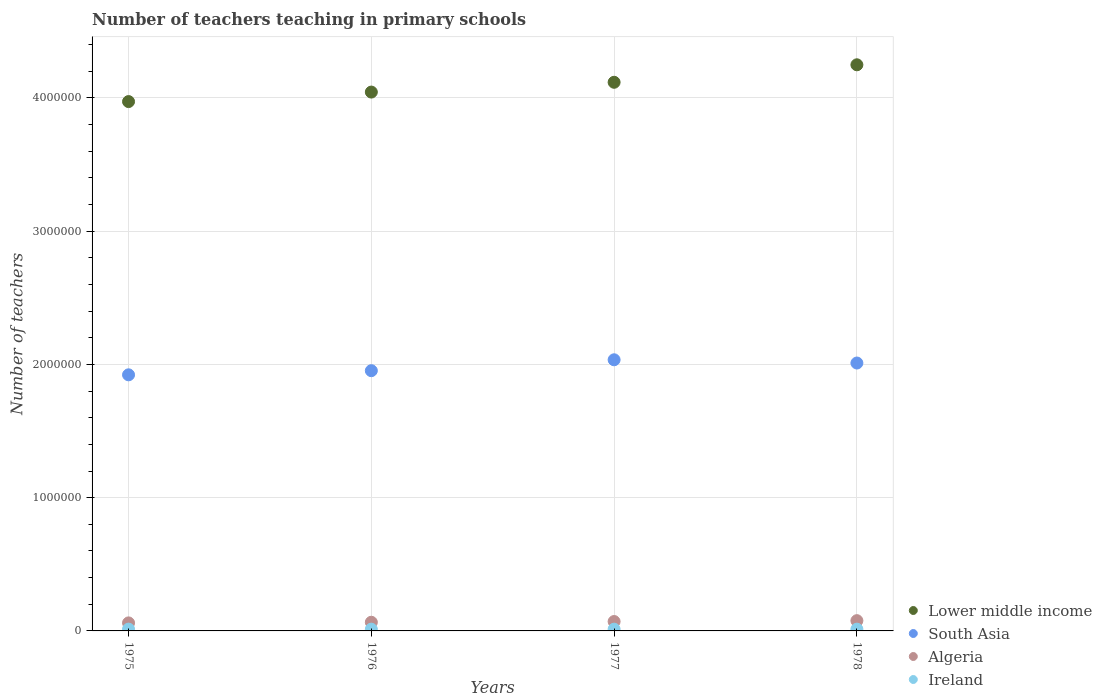Is the number of dotlines equal to the number of legend labels?
Your answer should be compact. Yes. What is the number of teachers teaching in primary schools in Algeria in 1975?
Keep it short and to the point. 6.02e+04. Across all years, what is the maximum number of teachers teaching in primary schools in South Asia?
Your answer should be very brief. 2.03e+06. Across all years, what is the minimum number of teachers teaching in primary schools in Algeria?
Your response must be concise. 6.02e+04. In which year was the number of teachers teaching in primary schools in Algeria maximum?
Offer a very short reply. 1978. In which year was the number of teachers teaching in primary schools in Ireland minimum?
Your answer should be very brief. 1976. What is the total number of teachers teaching in primary schools in South Asia in the graph?
Make the answer very short. 7.92e+06. What is the difference between the number of teachers teaching in primary schools in Algeria in 1976 and that in 1977?
Ensure brevity in your answer.  -5455. What is the difference between the number of teachers teaching in primary schools in Lower middle income in 1976 and the number of teachers teaching in primary schools in Algeria in 1977?
Your answer should be compact. 3.97e+06. What is the average number of teachers teaching in primary schools in Lower middle income per year?
Give a very brief answer. 4.10e+06. In the year 1977, what is the difference between the number of teachers teaching in primary schools in Ireland and number of teachers teaching in primary schools in South Asia?
Give a very brief answer. -2.02e+06. What is the ratio of the number of teachers teaching in primary schools in Algeria in 1975 to that in 1976?
Your answer should be compact. 0.93. Is the number of teachers teaching in primary schools in Algeria in 1977 less than that in 1978?
Ensure brevity in your answer.  Yes. Is the difference between the number of teachers teaching in primary schools in Ireland in 1975 and 1977 greater than the difference between the number of teachers teaching in primary schools in South Asia in 1975 and 1977?
Ensure brevity in your answer.  Yes. What is the difference between the highest and the second highest number of teachers teaching in primary schools in Ireland?
Offer a terse response. 155. What is the difference between the highest and the lowest number of teachers teaching in primary schools in Algeria?
Offer a very short reply. 1.68e+04. In how many years, is the number of teachers teaching in primary schools in South Asia greater than the average number of teachers teaching in primary schools in South Asia taken over all years?
Give a very brief answer. 2. Is the number of teachers teaching in primary schools in South Asia strictly greater than the number of teachers teaching in primary schools in Lower middle income over the years?
Your answer should be very brief. No. How many dotlines are there?
Keep it short and to the point. 4. How many years are there in the graph?
Provide a short and direct response. 4. What is the difference between two consecutive major ticks on the Y-axis?
Ensure brevity in your answer.  1.00e+06. Are the values on the major ticks of Y-axis written in scientific E-notation?
Offer a terse response. No. Does the graph contain any zero values?
Your answer should be very brief. No. Does the graph contain grids?
Your response must be concise. Yes. What is the title of the graph?
Your response must be concise. Number of teachers teaching in primary schools. What is the label or title of the Y-axis?
Your response must be concise. Number of teachers. What is the Number of teachers of Lower middle income in 1975?
Ensure brevity in your answer.  3.97e+06. What is the Number of teachers in South Asia in 1975?
Make the answer very short. 1.92e+06. What is the Number of teachers in Algeria in 1975?
Your answer should be compact. 6.02e+04. What is the Number of teachers in Ireland in 1975?
Your answer should be compact. 1.34e+04. What is the Number of teachers of Lower middle income in 1976?
Make the answer very short. 4.04e+06. What is the Number of teachers in South Asia in 1976?
Keep it short and to the point. 1.95e+06. What is the Number of teachers of Algeria in 1976?
Provide a short and direct response. 6.50e+04. What is the Number of teachers of Ireland in 1976?
Give a very brief answer. 1.31e+04. What is the Number of teachers of Lower middle income in 1977?
Offer a very short reply. 4.12e+06. What is the Number of teachers of South Asia in 1977?
Give a very brief answer. 2.03e+06. What is the Number of teachers in Algeria in 1977?
Make the answer very short. 7.05e+04. What is the Number of teachers of Ireland in 1977?
Provide a succinct answer. 1.31e+04. What is the Number of teachers of Lower middle income in 1978?
Your answer should be very brief. 4.25e+06. What is the Number of teachers of South Asia in 1978?
Keep it short and to the point. 2.01e+06. What is the Number of teachers in Algeria in 1978?
Provide a short and direct response. 7.70e+04. What is the Number of teachers in Ireland in 1978?
Offer a very short reply. 1.32e+04. Across all years, what is the maximum Number of teachers of Lower middle income?
Provide a short and direct response. 4.25e+06. Across all years, what is the maximum Number of teachers in South Asia?
Your answer should be very brief. 2.03e+06. Across all years, what is the maximum Number of teachers in Algeria?
Your answer should be very brief. 7.70e+04. Across all years, what is the maximum Number of teachers of Ireland?
Give a very brief answer. 1.34e+04. Across all years, what is the minimum Number of teachers of Lower middle income?
Your response must be concise. 3.97e+06. Across all years, what is the minimum Number of teachers of South Asia?
Provide a short and direct response. 1.92e+06. Across all years, what is the minimum Number of teachers in Algeria?
Provide a short and direct response. 6.02e+04. Across all years, what is the minimum Number of teachers in Ireland?
Give a very brief answer. 1.31e+04. What is the total Number of teachers of Lower middle income in the graph?
Provide a succinct answer. 1.64e+07. What is the total Number of teachers in South Asia in the graph?
Provide a succinct answer. 7.92e+06. What is the total Number of teachers in Algeria in the graph?
Offer a terse response. 2.73e+05. What is the total Number of teachers in Ireland in the graph?
Your response must be concise. 5.28e+04. What is the difference between the Number of teachers of Lower middle income in 1975 and that in 1976?
Your answer should be compact. -7.14e+04. What is the difference between the Number of teachers of South Asia in 1975 and that in 1976?
Offer a very short reply. -3.11e+04. What is the difference between the Number of teachers in Algeria in 1975 and that in 1976?
Offer a very short reply. -4864. What is the difference between the Number of teachers of Ireland in 1975 and that in 1976?
Offer a very short reply. 337. What is the difference between the Number of teachers of Lower middle income in 1975 and that in 1977?
Provide a succinct answer. -1.45e+05. What is the difference between the Number of teachers in South Asia in 1975 and that in 1977?
Provide a succinct answer. -1.13e+05. What is the difference between the Number of teachers in Algeria in 1975 and that in 1977?
Your answer should be very brief. -1.03e+04. What is the difference between the Number of teachers of Ireland in 1975 and that in 1977?
Offer a very short reply. 321. What is the difference between the Number of teachers in Lower middle income in 1975 and that in 1978?
Your answer should be compact. -2.76e+05. What is the difference between the Number of teachers of South Asia in 1975 and that in 1978?
Provide a succinct answer. -8.86e+04. What is the difference between the Number of teachers in Algeria in 1975 and that in 1978?
Ensure brevity in your answer.  -1.68e+04. What is the difference between the Number of teachers of Ireland in 1975 and that in 1978?
Your answer should be very brief. 155. What is the difference between the Number of teachers of Lower middle income in 1976 and that in 1977?
Make the answer very short. -7.35e+04. What is the difference between the Number of teachers of South Asia in 1976 and that in 1977?
Your answer should be very brief. -8.18e+04. What is the difference between the Number of teachers of Algeria in 1976 and that in 1977?
Your answer should be compact. -5455. What is the difference between the Number of teachers in Ireland in 1976 and that in 1977?
Provide a short and direct response. -16. What is the difference between the Number of teachers of Lower middle income in 1976 and that in 1978?
Ensure brevity in your answer.  -2.05e+05. What is the difference between the Number of teachers of South Asia in 1976 and that in 1978?
Provide a short and direct response. -5.75e+04. What is the difference between the Number of teachers in Algeria in 1976 and that in 1978?
Make the answer very short. -1.20e+04. What is the difference between the Number of teachers in Ireland in 1976 and that in 1978?
Make the answer very short. -182. What is the difference between the Number of teachers in Lower middle income in 1977 and that in 1978?
Offer a terse response. -1.31e+05. What is the difference between the Number of teachers in South Asia in 1977 and that in 1978?
Your answer should be very brief. 2.43e+04. What is the difference between the Number of teachers of Algeria in 1977 and that in 1978?
Your response must be concise. -6511. What is the difference between the Number of teachers in Ireland in 1977 and that in 1978?
Make the answer very short. -166. What is the difference between the Number of teachers of Lower middle income in 1975 and the Number of teachers of South Asia in 1976?
Ensure brevity in your answer.  2.02e+06. What is the difference between the Number of teachers in Lower middle income in 1975 and the Number of teachers in Algeria in 1976?
Offer a terse response. 3.91e+06. What is the difference between the Number of teachers in Lower middle income in 1975 and the Number of teachers in Ireland in 1976?
Give a very brief answer. 3.96e+06. What is the difference between the Number of teachers of South Asia in 1975 and the Number of teachers of Algeria in 1976?
Your answer should be very brief. 1.86e+06. What is the difference between the Number of teachers in South Asia in 1975 and the Number of teachers in Ireland in 1976?
Keep it short and to the point. 1.91e+06. What is the difference between the Number of teachers in Algeria in 1975 and the Number of teachers in Ireland in 1976?
Your answer should be compact. 4.71e+04. What is the difference between the Number of teachers of Lower middle income in 1975 and the Number of teachers of South Asia in 1977?
Provide a short and direct response. 1.94e+06. What is the difference between the Number of teachers of Lower middle income in 1975 and the Number of teachers of Algeria in 1977?
Make the answer very short. 3.90e+06. What is the difference between the Number of teachers of Lower middle income in 1975 and the Number of teachers of Ireland in 1977?
Offer a very short reply. 3.96e+06. What is the difference between the Number of teachers of South Asia in 1975 and the Number of teachers of Algeria in 1977?
Offer a terse response. 1.85e+06. What is the difference between the Number of teachers in South Asia in 1975 and the Number of teachers in Ireland in 1977?
Give a very brief answer. 1.91e+06. What is the difference between the Number of teachers of Algeria in 1975 and the Number of teachers of Ireland in 1977?
Offer a very short reply. 4.71e+04. What is the difference between the Number of teachers in Lower middle income in 1975 and the Number of teachers in South Asia in 1978?
Your response must be concise. 1.96e+06. What is the difference between the Number of teachers in Lower middle income in 1975 and the Number of teachers in Algeria in 1978?
Give a very brief answer. 3.90e+06. What is the difference between the Number of teachers of Lower middle income in 1975 and the Number of teachers of Ireland in 1978?
Your answer should be very brief. 3.96e+06. What is the difference between the Number of teachers of South Asia in 1975 and the Number of teachers of Algeria in 1978?
Keep it short and to the point. 1.84e+06. What is the difference between the Number of teachers in South Asia in 1975 and the Number of teachers in Ireland in 1978?
Ensure brevity in your answer.  1.91e+06. What is the difference between the Number of teachers in Algeria in 1975 and the Number of teachers in Ireland in 1978?
Your answer should be compact. 4.69e+04. What is the difference between the Number of teachers in Lower middle income in 1976 and the Number of teachers in South Asia in 1977?
Provide a short and direct response. 2.01e+06. What is the difference between the Number of teachers of Lower middle income in 1976 and the Number of teachers of Algeria in 1977?
Offer a very short reply. 3.97e+06. What is the difference between the Number of teachers in Lower middle income in 1976 and the Number of teachers in Ireland in 1977?
Give a very brief answer. 4.03e+06. What is the difference between the Number of teachers of South Asia in 1976 and the Number of teachers of Algeria in 1977?
Your response must be concise. 1.88e+06. What is the difference between the Number of teachers of South Asia in 1976 and the Number of teachers of Ireland in 1977?
Your answer should be compact. 1.94e+06. What is the difference between the Number of teachers of Algeria in 1976 and the Number of teachers of Ireland in 1977?
Your response must be concise. 5.20e+04. What is the difference between the Number of teachers of Lower middle income in 1976 and the Number of teachers of South Asia in 1978?
Ensure brevity in your answer.  2.03e+06. What is the difference between the Number of teachers in Lower middle income in 1976 and the Number of teachers in Algeria in 1978?
Provide a succinct answer. 3.97e+06. What is the difference between the Number of teachers in Lower middle income in 1976 and the Number of teachers in Ireland in 1978?
Your answer should be very brief. 4.03e+06. What is the difference between the Number of teachers of South Asia in 1976 and the Number of teachers of Algeria in 1978?
Your answer should be compact. 1.88e+06. What is the difference between the Number of teachers of South Asia in 1976 and the Number of teachers of Ireland in 1978?
Your answer should be compact. 1.94e+06. What is the difference between the Number of teachers in Algeria in 1976 and the Number of teachers in Ireland in 1978?
Provide a short and direct response. 5.18e+04. What is the difference between the Number of teachers of Lower middle income in 1977 and the Number of teachers of South Asia in 1978?
Provide a short and direct response. 2.11e+06. What is the difference between the Number of teachers of Lower middle income in 1977 and the Number of teachers of Algeria in 1978?
Provide a succinct answer. 4.04e+06. What is the difference between the Number of teachers of Lower middle income in 1977 and the Number of teachers of Ireland in 1978?
Your response must be concise. 4.10e+06. What is the difference between the Number of teachers in South Asia in 1977 and the Number of teachers in Algeria in 1978?
Give a very brief answer. 1.96e+06. What is the difference between the Number of teachers in South Asia in 1977 and the Number of teachers in Ireland in 1978?
Your answer should be very brief. 2.02e+06. What is the difference between the Number of teachers of Algeria in 1977 and the Number of teachers of Ireland in 1978?
Your response must be concise. 5.73e+04. What is the average Number of teachers in Lower middle income per year?
Keep it short and to the point. 4.10e+06. What is the average Number of teachers of South Asia per year?
Give a very brief answer. 1.98e+06. What is the average Number of teachers in Algeria per year?
Make the answer very short. 6.82e+04. What is the average Number of teachers of Ireland per year?
Your answer should be very brief. 1.32e+04. In the year 1975, what is the difference between the Number of teachers in Lower middle income and Number of teachers in South Asia?
Your answer should be very brief. 2.05e+06. In the year 1975, what is the difference between the Number of teachers in Lower middle income and Number of teachers in Algeria?
Your response must be concise. 3.91e+06. In the year 1975, what is the difference between the Number of teachers of Lower middle income and Number of teachers of Ireland?
Your response must be concise. 3.96e+06. In the year 1975, what is the difference between the Number of teachers in South Asia and Number of teachers in Algeria?
Provide a short and direct response. 1.86e+06. In the year 1975, what is the difference between the Number of teachers of South Asia and Number of teachers of Ireland?
Ensure brevity in your answer.  1.91e+06. In the year 1975, what is the difference between the Number of teachers of Algeria and Number of teachers of Ireland?
Your answer should be compact. 4.68e+04. In the year 1976, what is the difference between the Number of teachers of Lower middle income and Number of teachers of South Asia?
Ensure brevity in your answer.  2.09e+06. In the year 1976, what is the difference between the Number of teachers in Lower middle income and Number of teachers in Algeria?
Offer a terse response. 3.98e+06. In the year 1976, what is the difference between the Number of teachers in Lower middle income and Number of teachers in Ireland?
Offer a very short reply. 4.03e+06. In the year 1976, what is the difference between the Number of teachers in South Asia and Number of teachers in Algeria?
Your answer should be compact. 1.89e+06. In the year 1976, what is the difference between the Number of teachers in South Asia and Number of teachers in Ireland?
Your answer should be very brief. 1.94e+06. In the year 1976, what is the difference between the Number of teachers in Algeria and Number of teachers in Ireland?
Your answer should be compact. 5.20e+04. In the year 1977, what is the difference between the Number of teachers of Lower middle income and Number of teachers of South Asia?
Provide a short and direct response. 2.08e+06. In the year 1977, what is the difference between the Number of teachers of Lower middle income and Number of teachers of Algeria?
Offer a very short reply. 4.05e+06. In the year 1977, what is the difference between the Number of teachers of Lower middle income and Number of teachers of Ireland?
Ensure brevity in your answer.  4.10e+06. In the year 1977, what is the difference between the Number of teachers in South Asia and Number of teachers in Algeria?
Your response must be concise. 1.96e+06. In the year 1977, what is the difference between the Number of teachers of South Asia and Number of teachers of Ireland?
Keep it short and to the point. 2.02e+06. In the year 1977, what is the difference between the Number of teachers of Algeria and Number of teachers of Ireland?
Offer a very short reply. 5.74e+04. In the year 1978, what is the difference between the Number of teachers in Lower middle income and Number of teachers in South Asia?
Provide a short and direct response. 2.24e+06. In the year 1978, what is the difference between the Number of teachers of Lower middle income and Number of teachers of Algeria?
Provide a short and direct response. 4.17e+06. In the year 1978, what is the difference between the Number of teachers in Lower middle income and Number of teachers in Ireland?
Your response must be concise. 4.24e+06. In the year 1978, what is the difference between the Number of teachers in South Asia and Number of teachers in Algeria?
Offer a terse response. 1.93e+06. In the year 1978, what is the difference between the Number of teachers of South Asia and Number of teachers of Ireland?
Offer a terse response. 2.00e+06. In the year 1978, what is the difference between the Number of teachers in Algeria and Number of teachers in Ireland?
Provide a short and direct response. 6.38e+04. What is the ratio of the Number of teachers of Lower middle income in 1975 to that in 1976?
Your answer should be very brief. 0.98. What is the ratio of the Number of teachers of South Asia in 1975 to that in 1976?
Provide a short and direct response. 0.98. What is the ratio of the Number of teachers in Algeria in 1975 to that in 1976?
Provide a succinct answer. 0.93. What is the ratio of the Number of teachers in Ireland in 1975 to that in 1976?
Your answer should be very brief. 1.03. What is the ratio of the Number of teachers in Lower middle income in 1975 to that in 1977?
Your answer should be compact. 0.96. What is the ratio of the Number of teachers in South Asia in 1975 to that in 1977?
Make the answer very short. 0.94. What is the ratio of the Number of teachers in Algeria in 1975 to that in 1977?
Make the answer very short. 0.85. What is the ratio of the Number of teachers in Ireland in 1975 to that in 1977?
Ensure brevity in your answer.  1.02. What is the ratio of the Number of teachers of Lower middle income in 1975 to that in 1978?
Keep it short and to the point. 0.94. What is the ratio of the Number of teachers of South Asia in 1975 to that in 1978?
Offer a very short reply. 0.96. What is the ratio of the Number of teachers of Algeria in 1975 to that in 1978?
Offer a very short reply. 0.78. What is the ratio of the Number of teachers in Ireland in 1975 to that in 1978?
Provide a short and direct response. 1.01. What is the ratio of the Number of teachers of Lower middle income in 1976 to that in 1977?
Provide a succinct answer. 0.98. What is the ratio of the Number of teachers of South Asia in 1976 to that in 1977?
Offer a very short reply. 0.96. What is the ratio of the Number of teachers of Algeria in 1976 to that in 1977?
Make the answer very short. 0.92. What is the ratio of the Number of teachers in Ireland in 1976 to that in 1977?
Your answer should be very brief. 1. What is the ratio of the Number of teachers in Lower middle income in 1976 to that in 1978?
Your answer should be very brief. 0.95. What is the ratio of the Number of teachers in South Asia in 1976 to that in 1978?
Your answer should be compact. 0.97. What is the ratio of the Number of teachers in Algeria in 1976 to that in 1978?
Your answer should be very brief. 0.84. What is the ratio of the Number of teachers of Ireland in 1976 to that in 1978?
Provide a short and direct response. 0.99. What is the ratio of the Number of teachers in Lower middle income in 1977 to that in 1978?
Keep it short and to the point. 0.97. What is the ratio of the Number of teachers of South Asia in 1977 to that in 1978?
Offer a terse response. 1.01. What is the ratio of the Number of teachers in Algeria in 1977 to that in 1978?
Your answer should be compact. 0.92. What is the ratio of the Number of teachers of Ireland in 1977 to that in 1978?
Your response must be concise. 0.99. What is the difference between the highest and the second highest Number of teachers in Lower middle income?
Offer a terse response. 1.31e+05. What is the difference between the highest and the second highest Number of teachers of South Asia?
Make the answer very short. 2.43e+04. What is the difference between the highest and the second highest Number of teachers of Algeria?
Offer a very short reply. 6511. What is the difference between the highest and the second highest Number of teachers in Ireland?
Give a very brief answer. 155. What is the difference between the highest and the lowest Number of teachers of Lower middle income?
Ensure brevity in your answer.  2.76e+05. What is the difference between the highest and the lowest Number of teachers of South Asia?
Give a very brief answer. 1.13e+05. What is the difference between the highest and the lowest Number of teachers of Algeria?
Your answer should be very brief. 1.68e+04. What is the difference between the highest and the lowest Number of teachers in Ireland?
Offer a terse response. 337. 